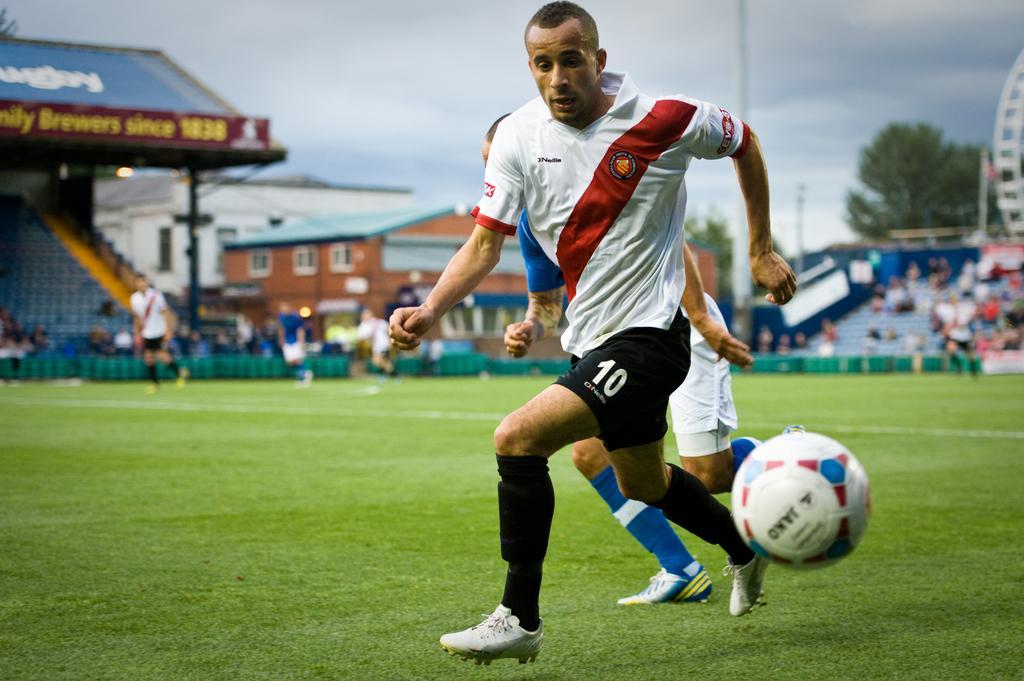In one or two sentences, can you explain what this image depicts? In the image there are two men in sports costume running on the grassland with a football beside them, in the back there are few men standing and walking, over the background there are stadium chairs followed by trees and buildings and above its sky with clouds. 